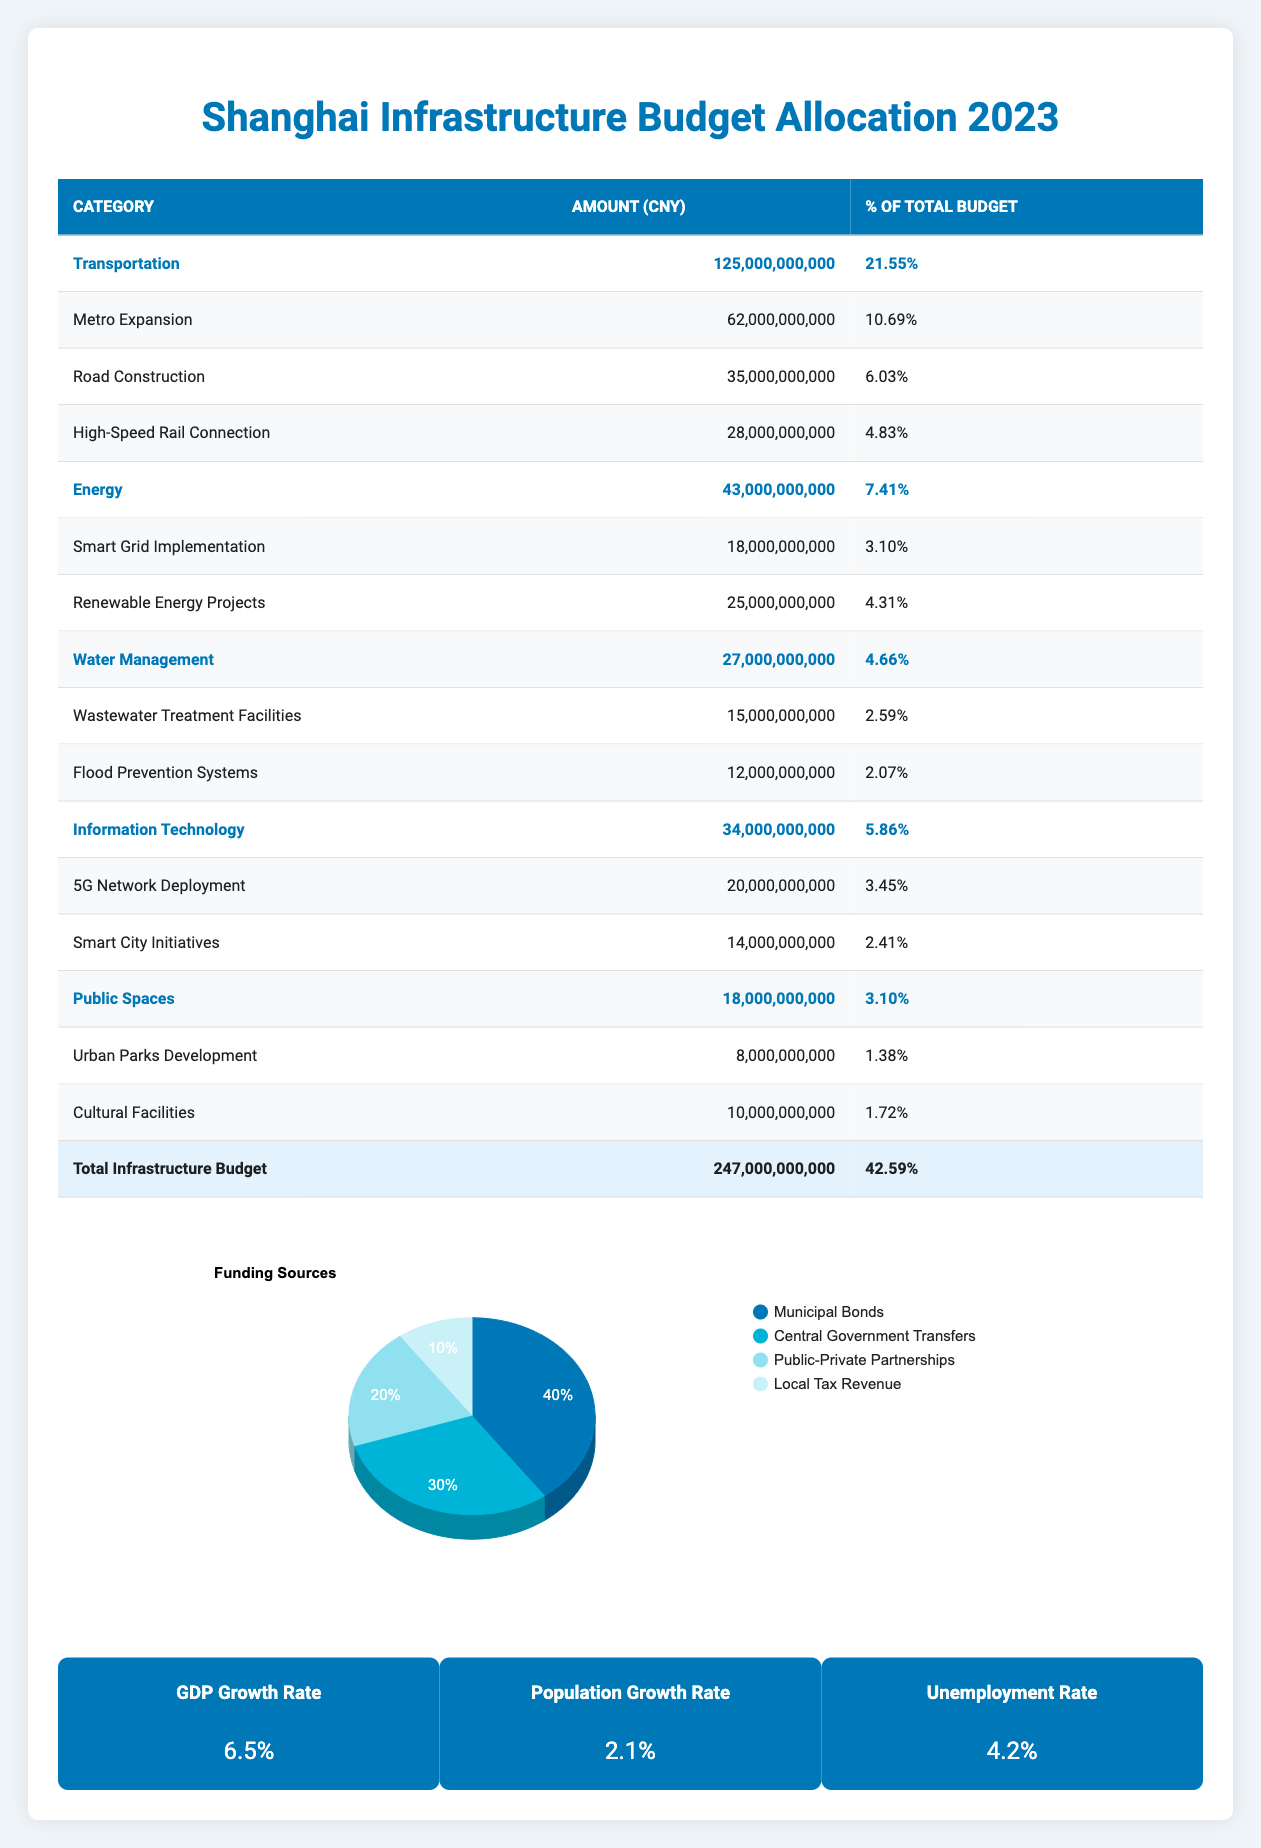What is the total amount allocated for Transportation? The table shows that the total allocation for Transportation is provided at the bottom of the relevant category, which states 125,000,000,000 CNY.
Answer: 125,000,000,000 CNY Which category received the highest allocation? The table lists the total allocations by category, and the highest total is for Transportation with 125,000,000,000 CNY, compared to others such as Energy and Water Management.
Answer: Transportation What percentage of the total budget is allocated for Renewable Energy Projects? Renewable Energy Projects are categorized under Energy, with a specific allocation amount indicated as 25,000,000,000 CNY. The percentage is calculated by (25,000,000,000 / 580,000,000,000) * 100, which equals approximately 4.31%.
Answer: 4.31% Is the total budget allocated for Infrastructure greater than 240 billion CNY? The total infrastructure budget shown in the table is 247,000,000,000 CNY, which is indeed greater than 240 billion CNY.
Answer: Yes What is the total allocation for Water Management subcategories? The subcategories under Water Management are Wastewater Treatment Facilities and Flood Prevention Systems, with amounts of 15,000,000,000 CNY and 12,000,000,000 CNY respectively. To find the total, we sum these amounts: 15,000,000,000 + 12,000,000,000 = 27,000,000,000 CNY.
Answer: 27,000,000,000 CNY What is the combined percentage of the total budget allocated for Public Spaces and Water Management? Public Spaces allocation is 18,000,000,000 CNY and Water Management is 27,000,000,000 CNY. The respective percentages are calculated as (18,000,000,000 / 580,000,000,000) * 100 and (27,000,000,000 / 580,000,000,000) * 100, which gives us approximately 3.10% + 4.66% = 7.76%.
Answer: 7.76% How much is allocated for Metro Expansion in terms of total budget percentage? The allocation for Metro Expansion is listed as 62,000,000,000 CNY. To find the percentage of the total budget, we calculate (62,000,000,000 / 580,000,000,000) * 100, which equals about 10.69%.
Answer: 10.69% Is the sum of subcategory allocations for Information Technology less than that for Energy? Information Technology total is 34,000,000,000 CNY and Energy total is 43,000,000,000 CNY. Since 34,000,000,000 is less than 43,000,000,000, the statement is true.
Answer: Yes What percentage of the funding sources comes from Local Tax Revenue? The table indicates that Local Tax Revenue contributes 10% to the total funding sources, showing the breakdown clearly.
Answer: 10% 